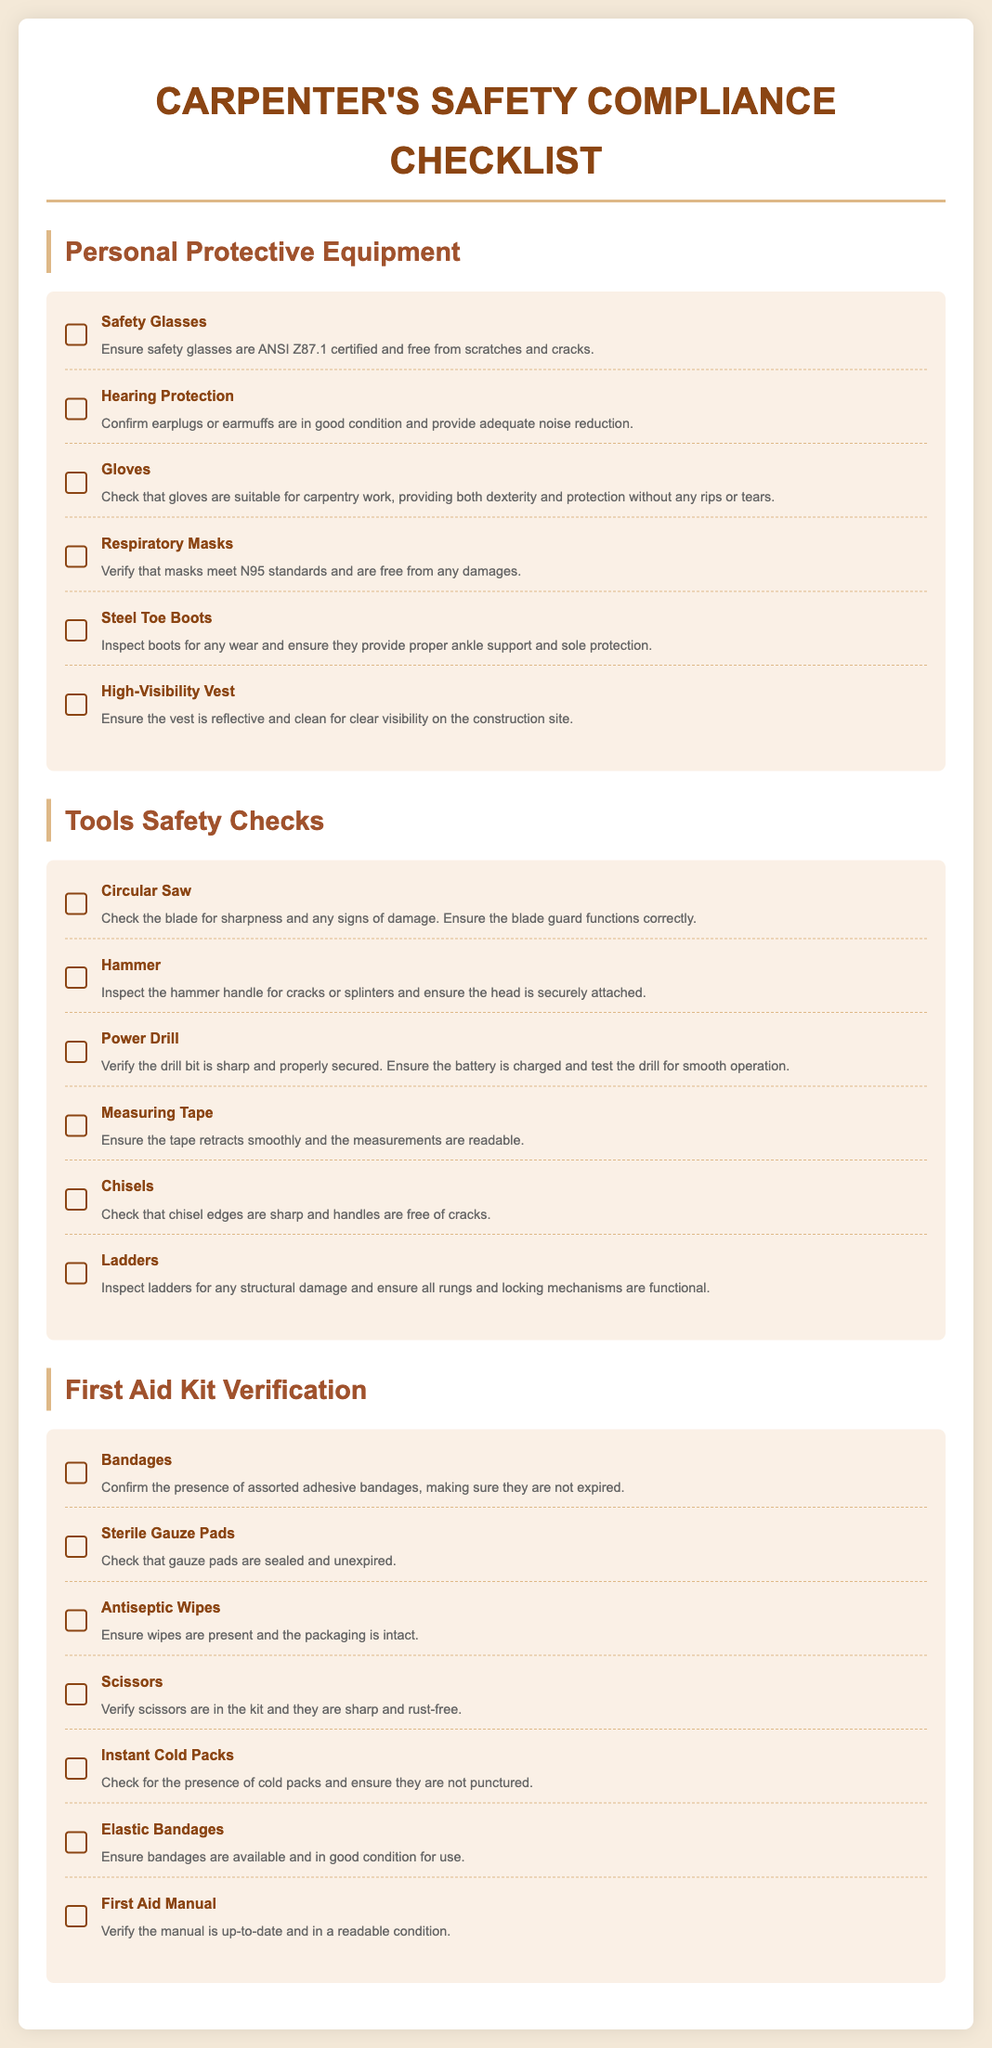What is the title of the checklist? The title appears prominently at the top of the document and is "Carpenter's Safety Compliance Checklist."
Answer: Carpenter's Safety Compliance Checklist How many categories are in the checklist? The checklist is divided into three main categories highlighted by headings, which are Personal Protective Equipment, Tools Safety Checks, and First Aid Kit Verification.
Answer: 3 What is the first item listed under Personal Protective Equipment? The first item is identified in the section titled Personal Protective Equipment, specifically focusing on Safety Glasses.
Answer: Safety Glasses What standards must the respiratory masks meet? The requirement for respiratory masks is noted in the respective item's description, emphasizing adherence to N95 standards.
Answer: N95 How many items are there in the Tools Safety Checks section? The Tools Safety Checks section lists six distinct tools that require safety checks, as indicated by the checklist items.
Answer: 6 What type of bandages must be in the first aid kit? The first-aid kit should include assorted adhesive bandages, as stated in the verification section regarding supplies.
Answer: Adhesive bandages What should be checked regarding the scissors in the First Aid Kit? The checklist specifies that the scissors must be sharp and rust-free, stating the condition that needs to be verified.
Answer: Sharp and rust-free Are there any requirements for steel toe boots? The item description for steel toe boots mentions requirements for wear, ankle support, and sole protection.
Answer: Yes, proper wear and support What is the purpose of high-visibility vests? The item description for high-visibility vests explains their main purpose is for clear visibility on the construction site.
Answer: Clear visibility 